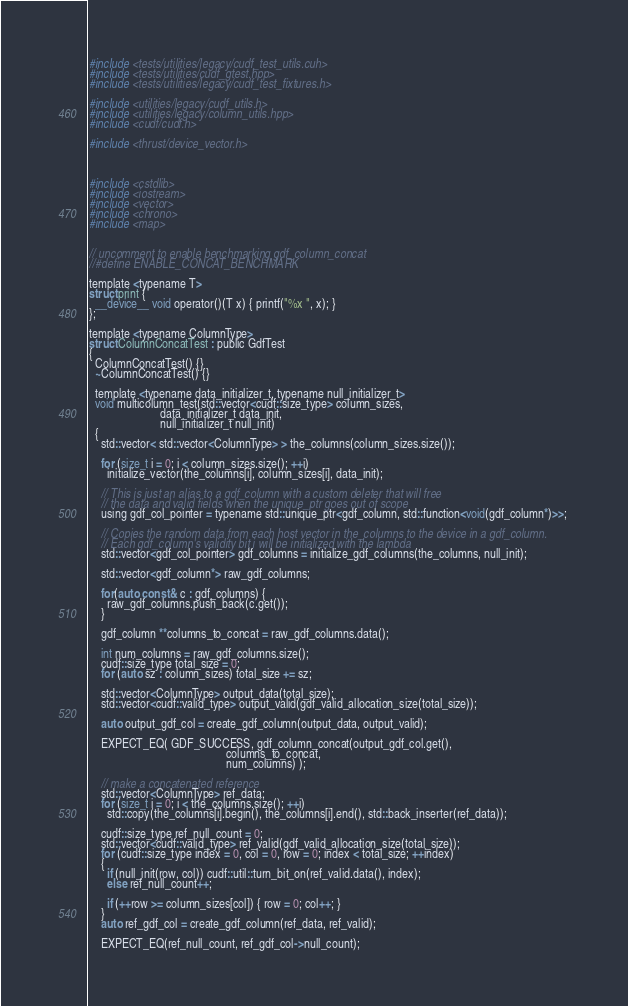<code> <loc_0><loc_0><loc_500><loc_500><_Cuda_>#include <tests/utilities/legacy/cudf_test_utils.cuh>
#include <tests/utilities/cudf_gtest.hpp>
#include <tests/utilities/legacy/cudf_test_fixtures.h>

#include <utilities/legacy/cudf_utils.h>
#include <utilities/legacy/column_utils.hpp>
#include <cudf/cudf.h>

#include <thrust/device_vector.h>



#include <cstdlib>
#include <iostream>
#include <vector>
#include <chrono>
#include <map>


// uncomment to enable benchmarking gdf_column_concat
//#define ENABLE_CONCAT_BENCHMARK 

template <typename T>
struct print {
  __device__ void operator()(T x) { printf("%x ", x); }
};

template <typename ColumnType>
struct ColumnConcatTest : public GdfTest
{
  ColumnConcatTest() {}
  ~ColumnConcatTest() {}
  
  template <typename data_initializer_t, typename null_initializer_t>
  void multicolumn_test(std::vector<cudf::size_type> column_sizes, 
                        data_initializer_t data_init, 
                        null_initializer_t null_init)
  { 
    std::vector< std::vector<ColumnType> > the_columns(column_sizes.size());

    for (size_t i = 0; i < column_sizes.size(); ++i)
      initialize_vector(the_columns[i], column_sizes[i], data_init);
    
    // This is just an alias to a gdf_column with a custom deleter that will free 
    // the data and valid fields when the unique_ptr goes out of scope
    using gdf_col_pointer = typename std::unique_ptr<gdf_column, std::function<void(gdf_column*)>>; 

    // Copies the random data from each host vector in the_columns to the device in a gdf_column. 
    // Each gdf_column's validity bit i will be initialized with the lambda
    std::vector<gdf_col_pointer> gdf_columns = initialize_gdf_columns(the_columns, null_init);

    std::vector<gdf_column*> raw_gdf_columns;

    for(auto const & c : gdf_columns) {
      raw_gdf_columns.push_back(c.get());
    }

    gdf_column **columns_to_concat = raw_gdf_columns.data();

    int num_columns = raw_gdf_columns.size();
    cudf::size_type total_size = 0;
    for (auto sz : column_sizes) total_size += sz;

    std::vector<ColumnType> output_data(total_size);
    std::vector<cudf::valid_type> output_valid(gdf_valid_allocation_size(total_size));
    
    auto output_gdf_col = create_gdf_column(output_data, output_valid);

    EXPECT_EQ( GDF_SUCCESS, gdf_column_concat(output_gdf_col.get(), 
                                              columns_to_concat, 
                                              num_columns) );

    // make a concatenated reference
    std::vector<ColumnType> ref_data;
    for (size_t i = 0; i < the_columns.size(); ++i)
      std::copy(the_columns[i].begin(), the_columns[i].end(), std::back_inserter(ref_data));
      
    cudf::size_type ref_null_count = 0;
    std::vector<cudf::valid_type> ref_valid(gdf_valid_allocation_size(total_size));
    for (cudf::size_type index = 0, col = 0, row = 0; index < total_size; ++index)
    {
      if (null_init(row, col)) cudf::util::turn_bit_on(ref_valid.data(), index);
      else ref_null_count++;
      
      if (++row >= column_sizes[col]) { row = 0; col++; }
    }   
    auto ref_gdf_col = create_gdf_column(ref_data, ref_valid);

    EXPECT_EQ(ref_null_count, ref_gdf_col->null_count);
</code> 